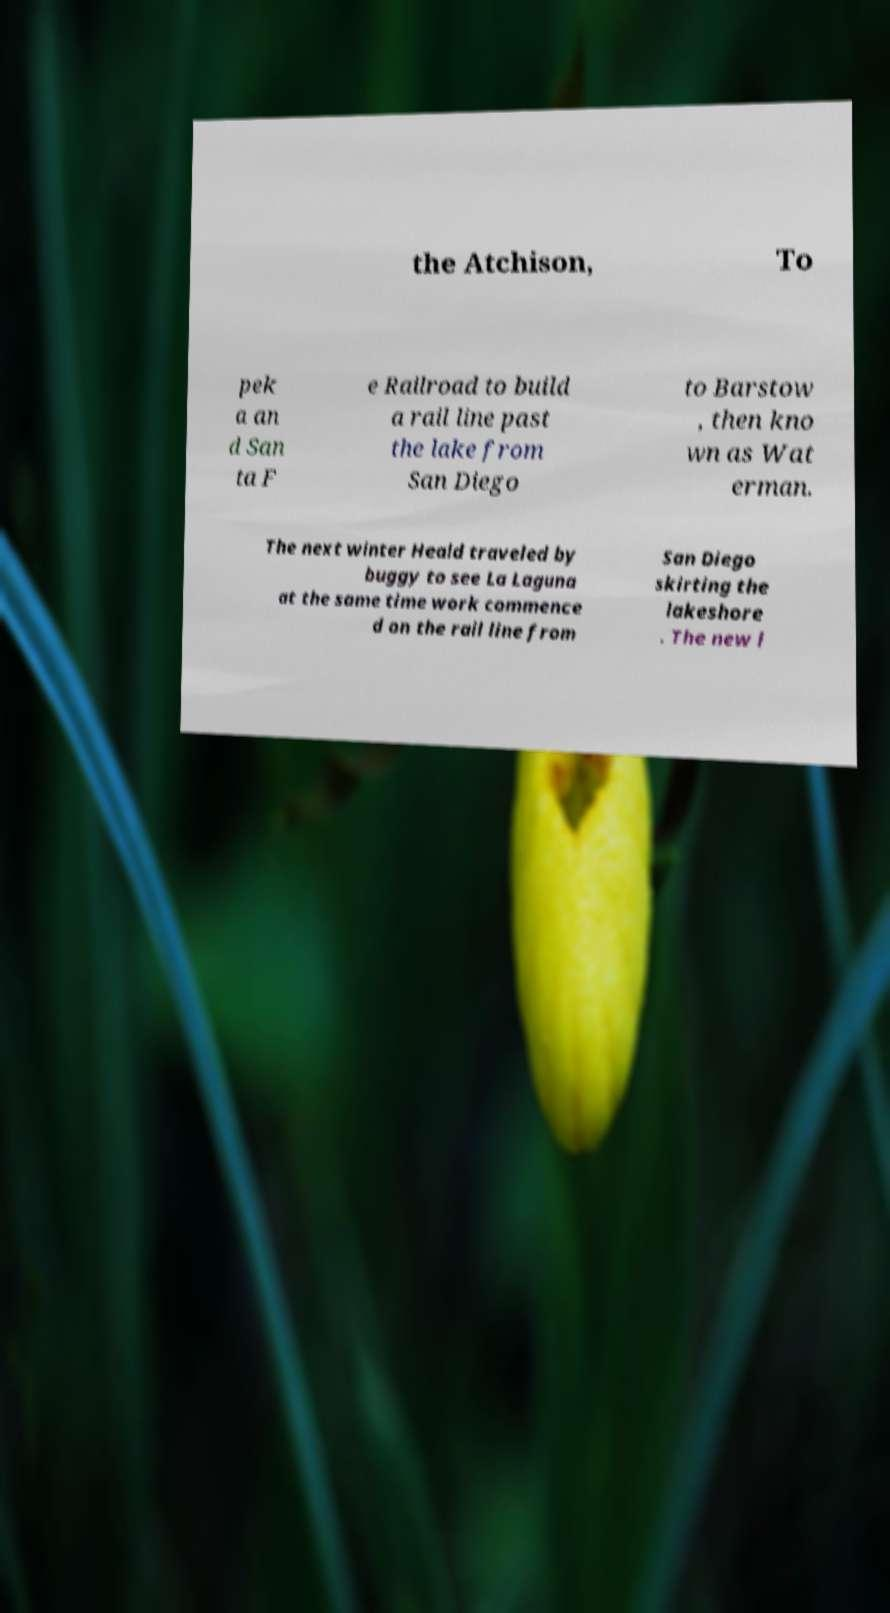Could you assist in decoding the text presented in this image and type it out clearly? the Atchison, To pek a an d San ta F e Railroad to build a rail line past the lake from San Diego to Barstow , then kno wn as Wat erman. The next winter Heald traveled by buggy to see La Laguna at the same time work commence d on the rail line from San Diego skirting the lakeshore . The new l 